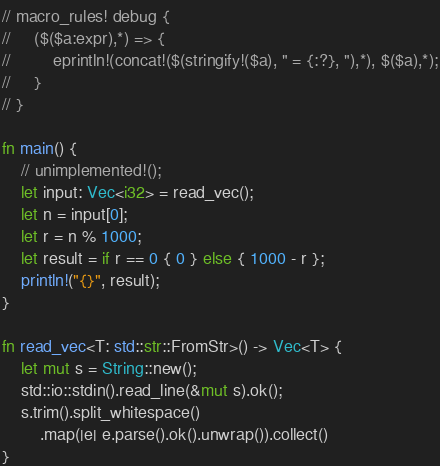Convert code to text. <code><loc_0><loc_0><loc_500><loc_500><_Rust_>// macro_rules! debug {
//     ($($a:expr),*) => {
//         eprintln!(concat!($(stringify!($a), " = {:?}, "),*), $($a),*);
//     }
// }

fn main() {
    // unimplemented!();
    let input: Vec<i32> = read_vec();
    let n = input[0];
    let r = n % 1000;
    let result = if r == 0 { 0 } else { 1000 - r };
    println!("{}", result);
}

fn read_vec<T: std::str::FromStr>() -> Vec<T> {
    let mut s = String::new();
    std::io::stdin().read_line(&mut s).ok();
    s.trim().split_whitespace()
        .map(|e| e.parse().ok().unwrap()).collect()
}</code> 